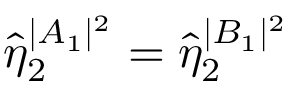Convert formula to latex. <formula><loc_0><loc_0><loc_500><loc_500>\hat { \eta } _ { 2 } ^ { | A _ { 1 } | ^ { 2 } } = \hat { \eta } _ { 2 } ^ { | B _ { 1 } | ^ { 2 } }</formula> 